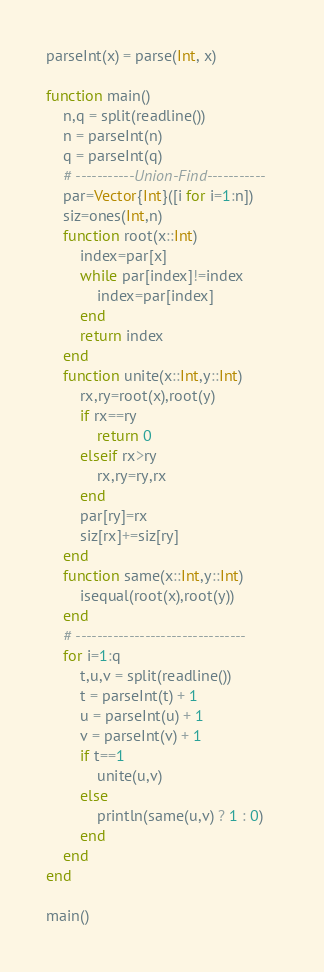<code> <loc_0><loc_0><loc_500><loc_500><_Julia_>parseInt(x) = parse(Int, x)

function main()
    n,q = split(readline())
    n = parseInt(n)
    q = parseInt(q)
    # -----------Union-Find-----------
    par=Vector{Int}([i for i=1:n])
    siz=ones(Int,n)
    function root(x::Int)
        index=par[x]
        while par[index]!=index
            index=par[index]
        end
        return index
    end
    function unite(x::Int,y::Int)
        rx,ry=root(x),root(y)
        if rx==ry
            return 0
        elseif rx>ry
            rx,ry=ry,rx
        end
        par[ry]=rx
        siz[rx]+=siz[ry]
    end
    function same(x::Int,y::Int)
        isequal(root(x),root(y))
    end
    # --------------------------------
    for i=1:q
        t,u,v = split(readline())
        t = parseInt(t) + 1
        u = parseInt(u) + 1
        v = parseInt(v) + 1
        if t==1
            unite(u,v)
        else
            println(same(u,v) ? 1 : 0)
        end
    end
end

main()
</code> 